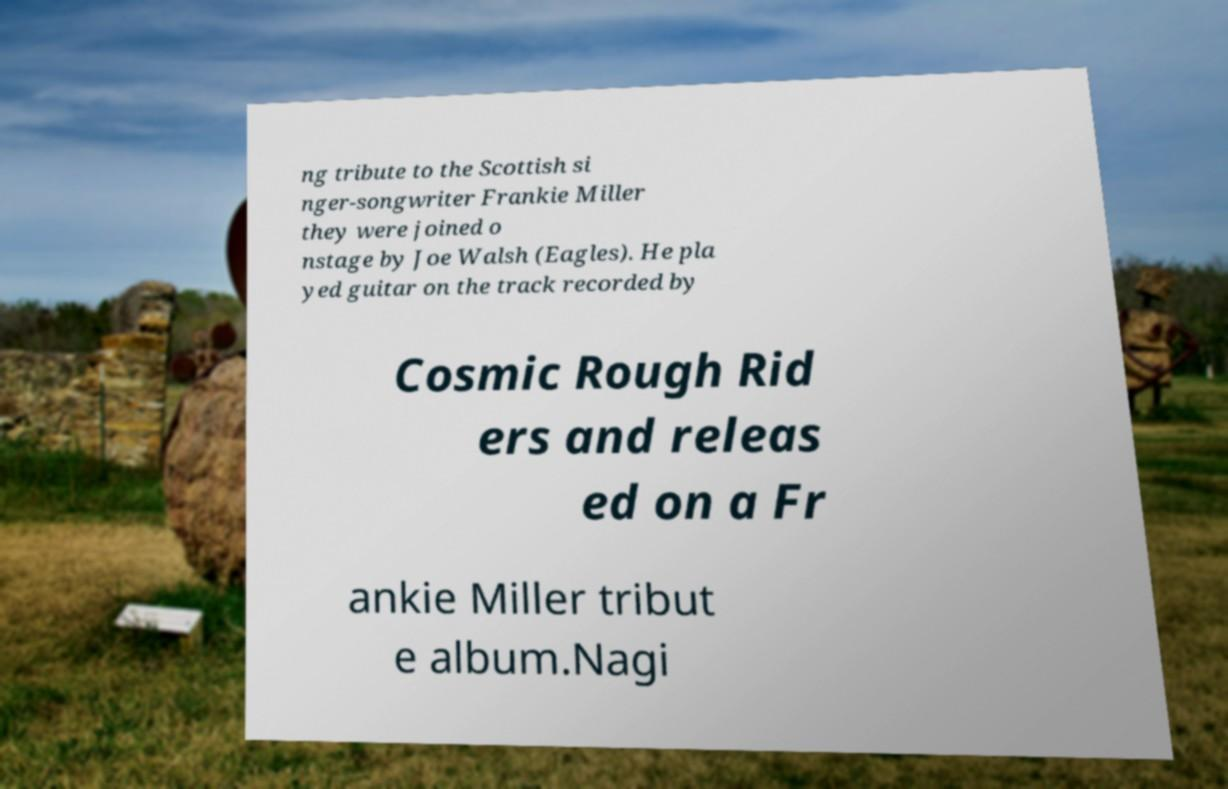I need the written content from this picture converted into text. Can you do that? ng tribute to the Scottish si nger-songwriter Frankie Miller they were joined o nstage by Joe Walsh (Eagles). He pla yed guitar on the track recorded by Cosmic Rough Rid ers and releas ed on a Fr ankie Miller tribut e album.Nagi 